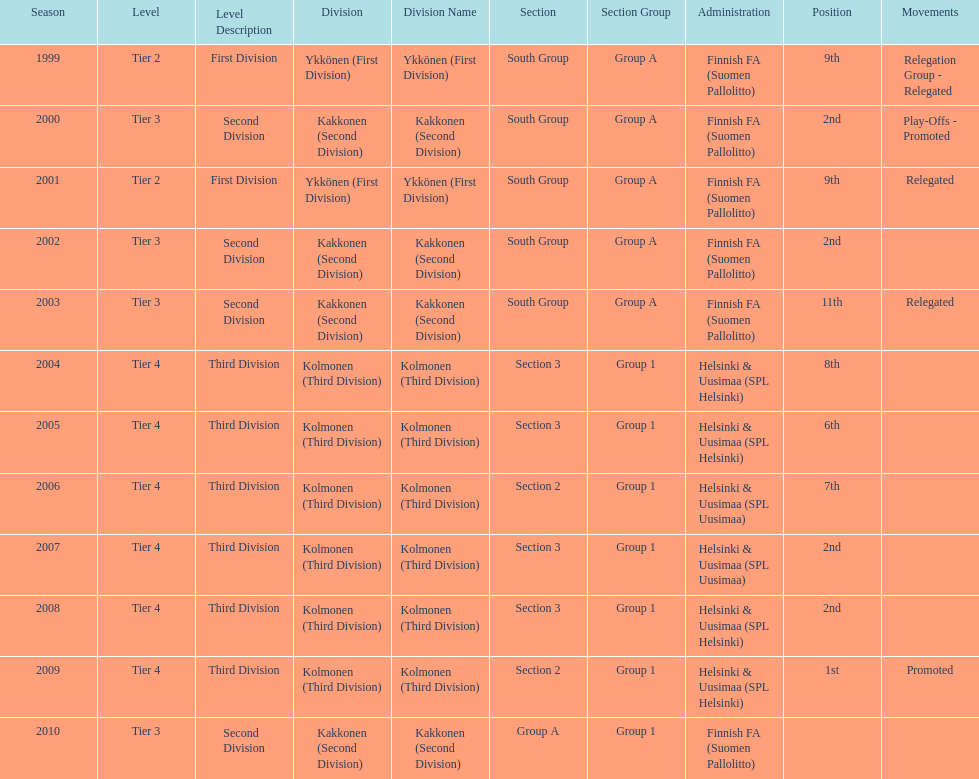Which was the only kolmonen whose movements were promoted? 2009. 